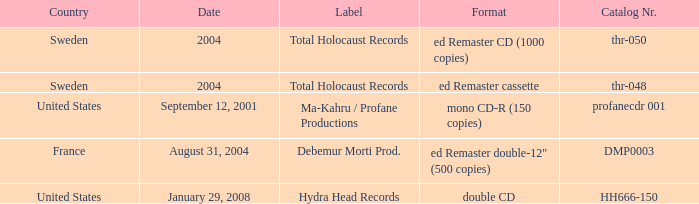Which country has the catalog nr of thr-048 in 2004? Sweden. 